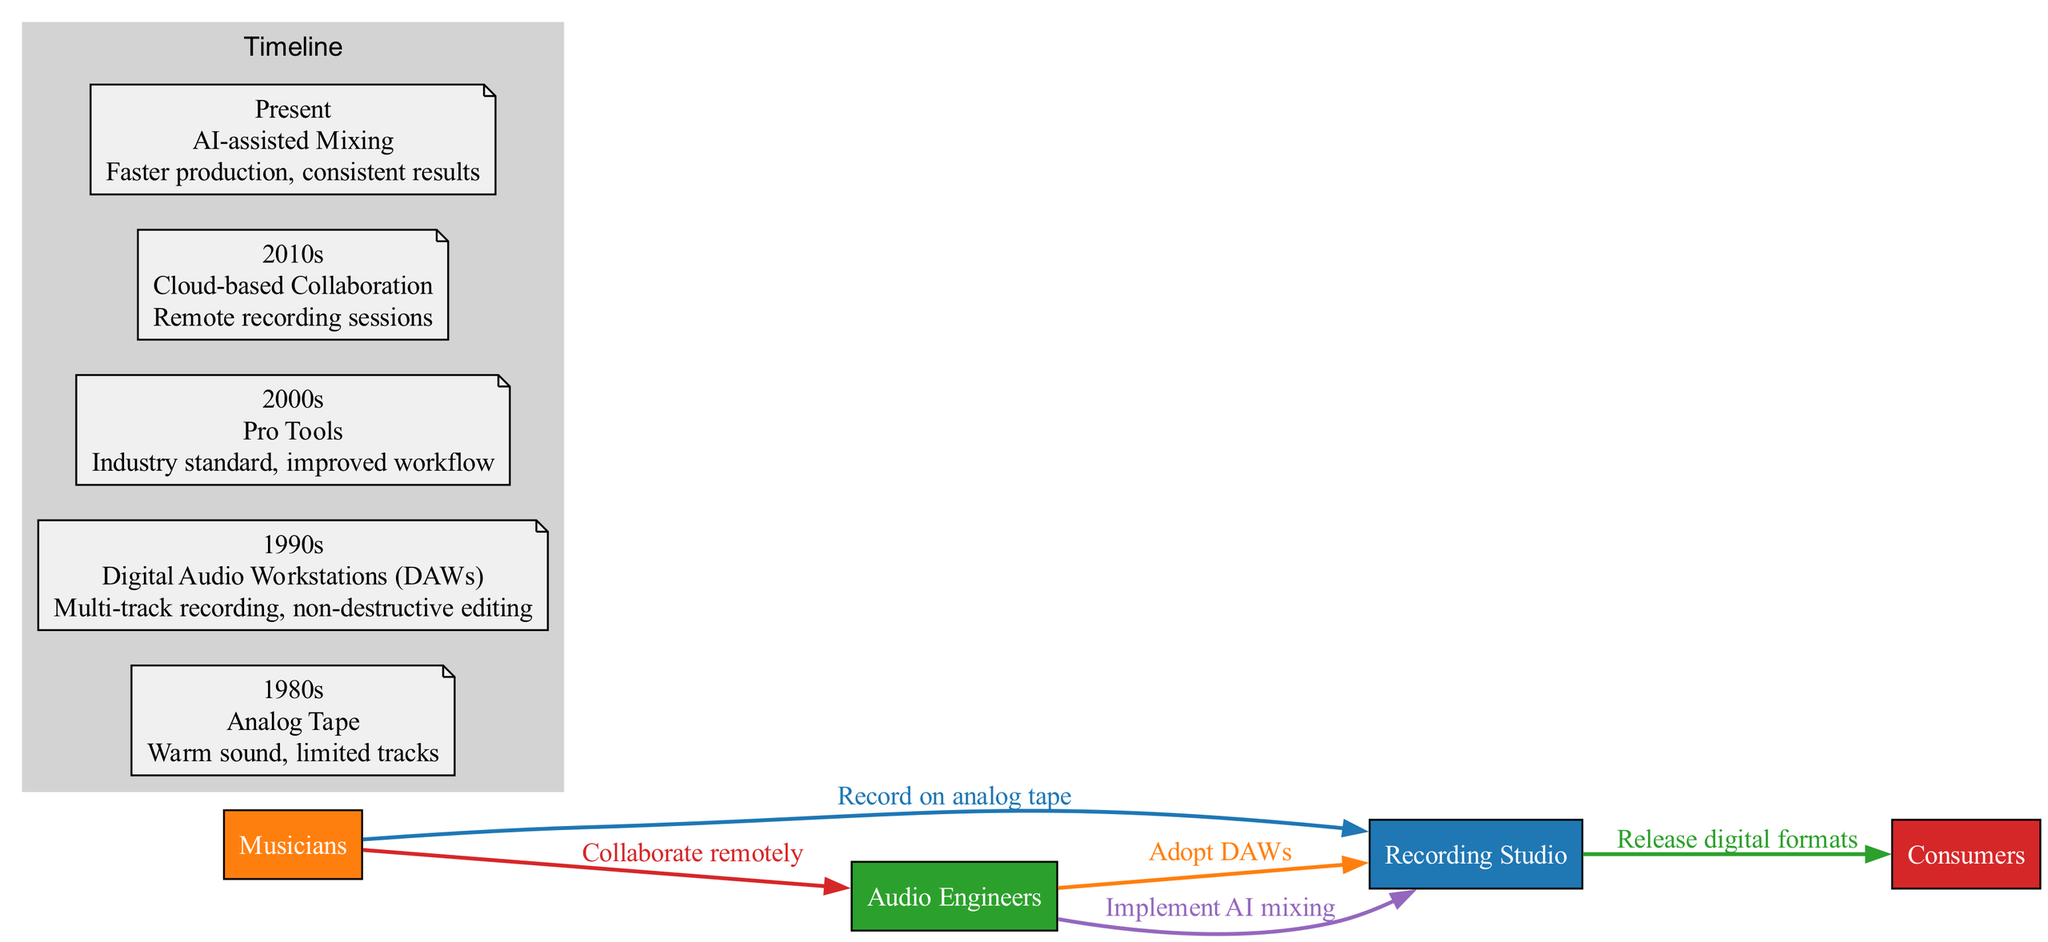What technology was used in the 1980s? According to the timeline section of the diagram, the technology used in the 1980s is listed as "Analog Tape."
Answer: Analog Tape In which decade did Pro Tools become the industry standard? Referring to the timeline, the decade in which Pro Tools became the industry standard is clearly marked as the 2000s.
Answer: 2000s What impact did the introduction of Cloud-based Collaboration have? The timeline indicates that Cloud-based Collaboration's impact was "Remote recording sessions," which signifies a shift toward flexibility in recording.
Answer: Remote recording sessions Who adopted Digital Audio Workstations? According to the interactions, it is stated that "Audio Engineers" adopted Digital Audio Workstations.
Answer: Audio Engineers How many technologies are displayed in the timeline? The timeline section of the diagram features a total of five technologies: Analog Tape, Digital Audio Workstations, Pro Tools, Cloud-based Collaboration, and AI-assisted Mixing.
Answer: Five What is the action taken by Musicians regarding analog tape? The interactions in the diagram demonstrate that the action taken by Musicians was to "Record on analog tape."
Answer: Record on analog tape Which actor implements AI mixing? As per the interactions, it is specified that "Audio Engineers" are the ones who implement AI mixing in the recording process.
Answer: Audio Engineers How has the role of Musicians changed over time according to the diagram? Analyzing the interactions, it shows that Musicians evolved from recording on analog tape to collaborating remotely with Audio Engineers, indicating a shift towards more integrated and flexible working methods.
Answer: Collaborating remotely What do Audio Engineers do in response to new technology advancements? The diagram shows that Audio Engineers have responded to technological advancements by adopting Digital Audio Workstations and later implementing AI mixing in the recording studio.
Answer: Adopt DAWs and implement AI mixing 